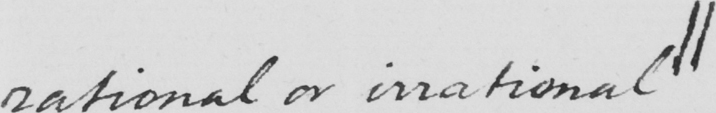Can you read and transcribe this handwriting? rational or irrational|| 